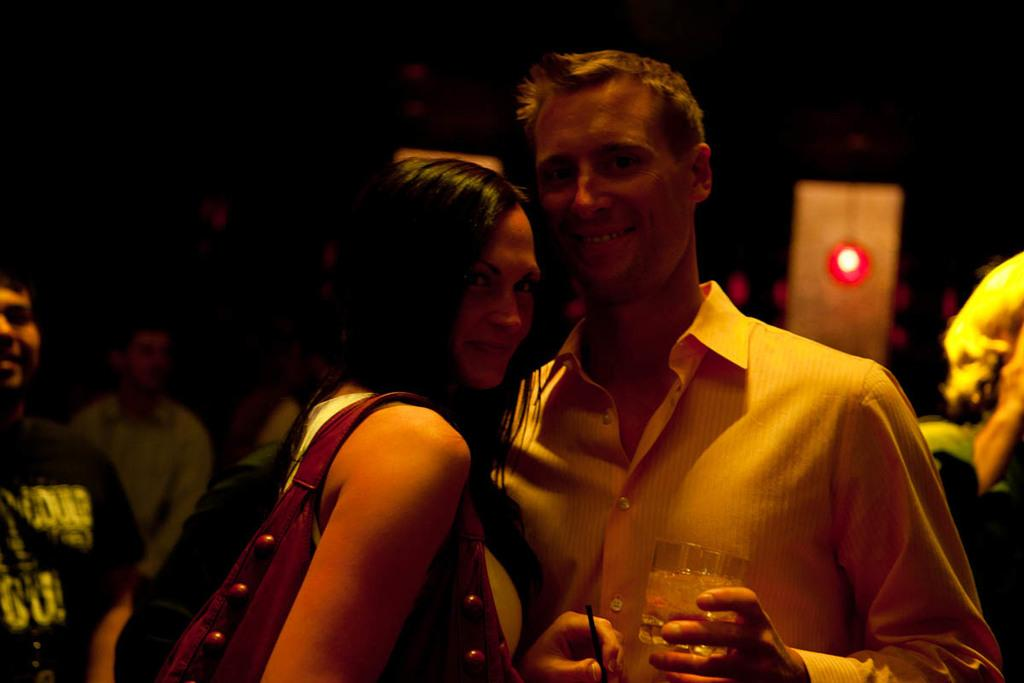What is happening in the image? There are people standing in the image. Where are the people standing? The people are standing on the floor. What is one of the people holding? One of the people is holding a glass tumbler in their hands. What type of sign can be seen in the image? There is no sign present in the image. Can you describe the swing in the image? There is no swing present in the image. 